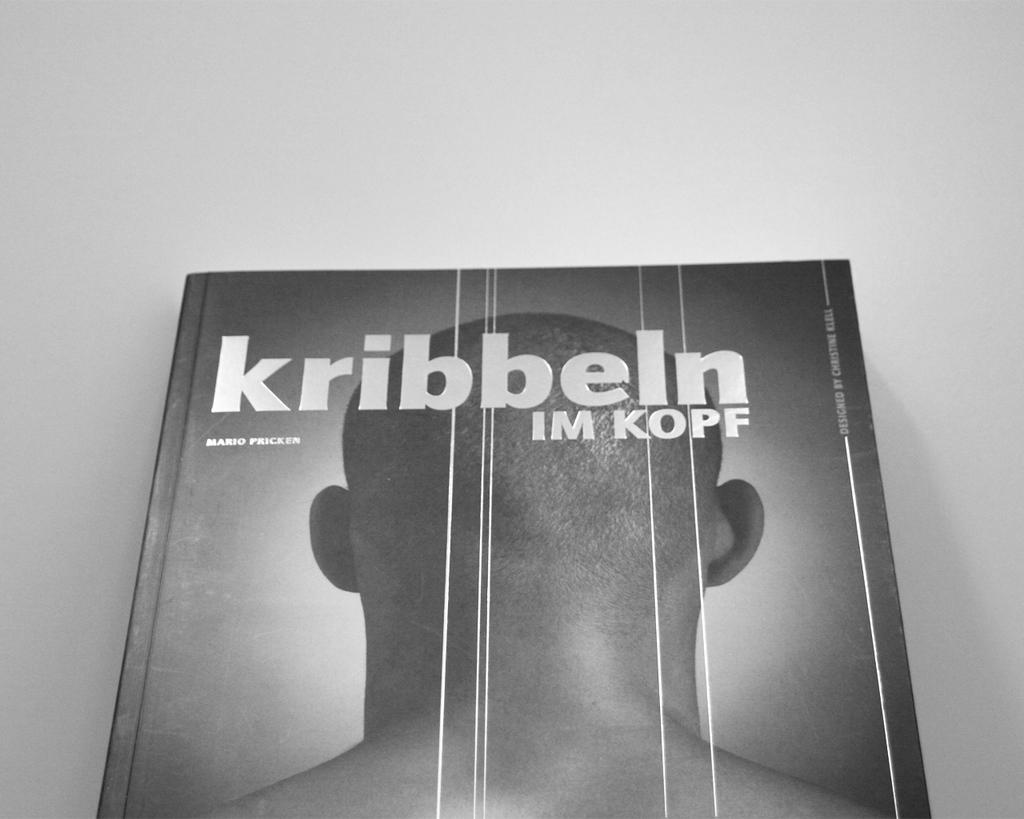What is the name of the book?
Ensure brevity in your answer.  Kribbeln. What is the first name of the author?
Your answer should be very brief. Mario. 